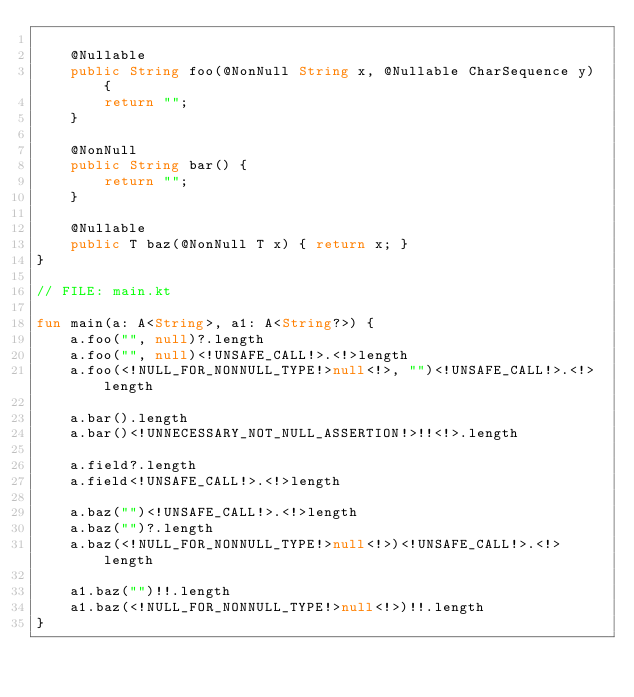Convert code to text. <code><loc_0><loc_0><loc_500><loc_500><_Kotlin_>
    @Nullable
    public String foo(@NonNull String x, @Nullable CharSequence y) {
        return "";
    }

    @NonNull
    public String bar() {
        return "";
    }

    @Nullable
    public T baz(@NonNull T x) { return x; }
}

// FILE: main.kt

fun main(a: A<String>, a1: A<String?>) {
    a.foo("", null)?.length
    a.foo("", null)<!UNSAFE_CALL!>.<!>length
    a.foo(<!NULL_FOR_NONNULL_TYPE!>null<!>, "")<!UNSAFE_CALL!>.<!>length

    a.bar().length
    a.bar()<!UNNECESSARY_NOT_NULL_ASSERTION!>!!<!>.length

    a.field?.length
    a.field<!UNSAFE_CALL!>.<!>length

    a.baz("")<!UNSAFE_CALL!>.<!>length
    a.baz("")?.length
    a.baz(<!NULL_FOR_NONNULL_TYPE!>null<!>)<!UNSAFE_CALL!>.<!>length

    a1.baz("")!!.length
    a1.baz(<!NULL_FOR_NONNULL_TYPE!>null<!>)!!.length
}
</code> 